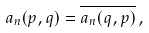Convert formula to latex. <formula><loc_0><loc_0><loc_500><loc_500>a _ { n } ( p , q ) = \overline { a _ { n } ( q , p ) } \, ,</formula> 